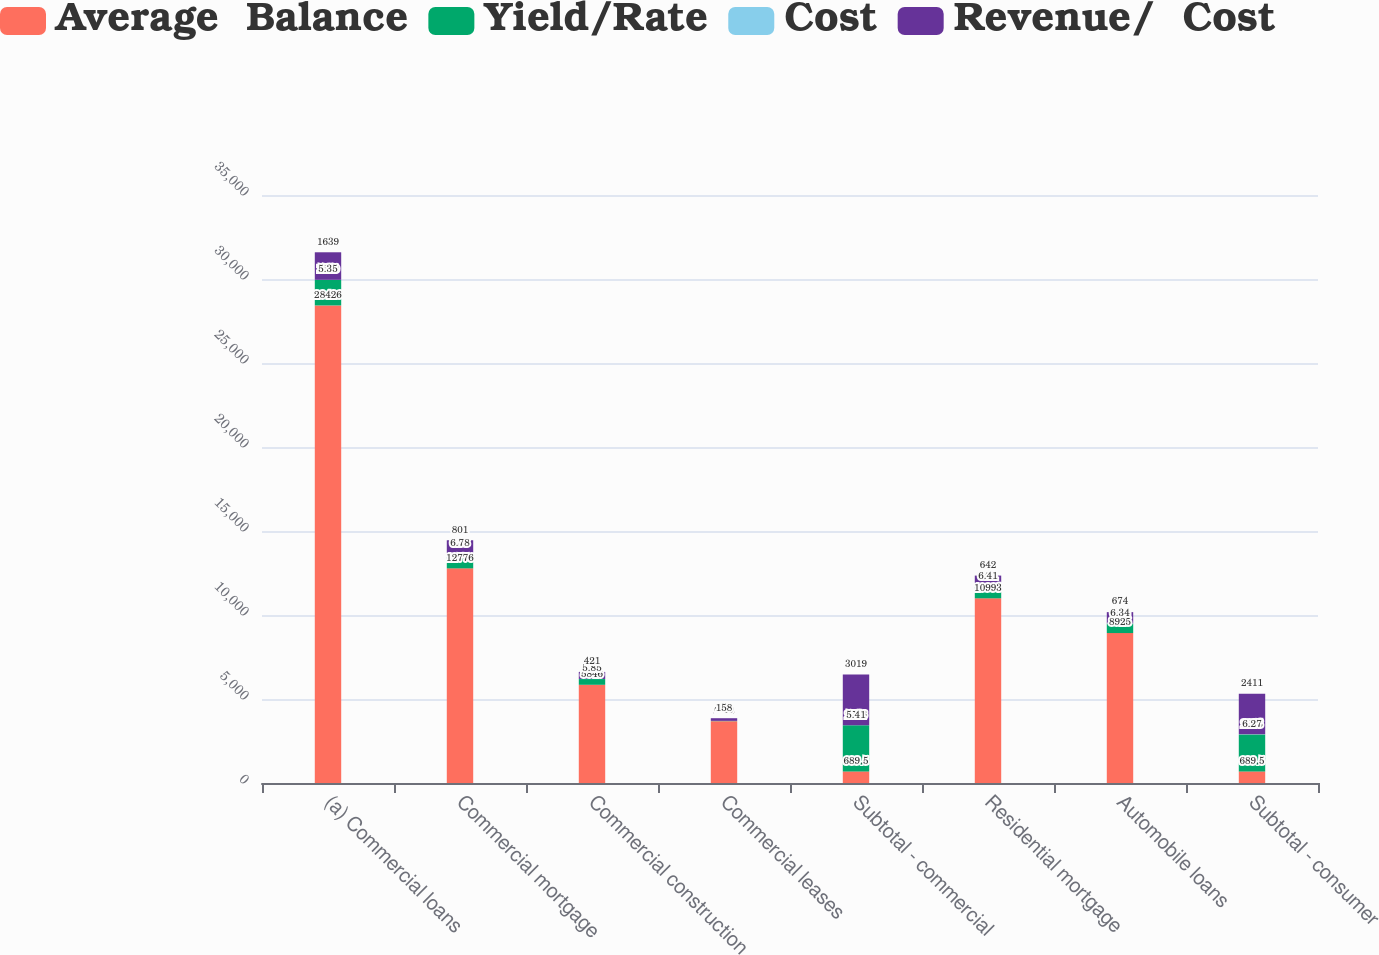Convert chart. <chart><loc_0><loc_0><loc_500><loc_500><stacked_bar_chart><ecel><fcel>(a) Commercial loans<fcel>Commercial mortgage<fcel>Commercial construction<fcel>Commercial leases<fcel>Subtotal - commercial<fcel>Residential mortgage<fcel>Automobile loans<fcel>Subtotal - consumer<nl><fcel>Average  Balance<fcel>28426<fcel>12776<fcel>5846<fcel>3680<fcel>689.5<fcel>10993<fcel>8925<fcel>689.5<nl><fcel>Yield/Rate<fcel>1520<fcel>866<fcel>342<fcel>18<fcel>2746<fcel>705<fcel>566<fcel>2203<nl><fcel>Cost<fcel>5.35<fcel>6.78<fcel>5.85<fcel>0.49<fcel>5.41<fcel>6.41<fcel>6.34<fcel>6.27<nl><fcel>Revenue/  Cost<fcel>1639<fcel>801<fcel>421<fcel>158<fcel>3019<fcel>642<fcel>674<fcel>2411<nl></chart> 